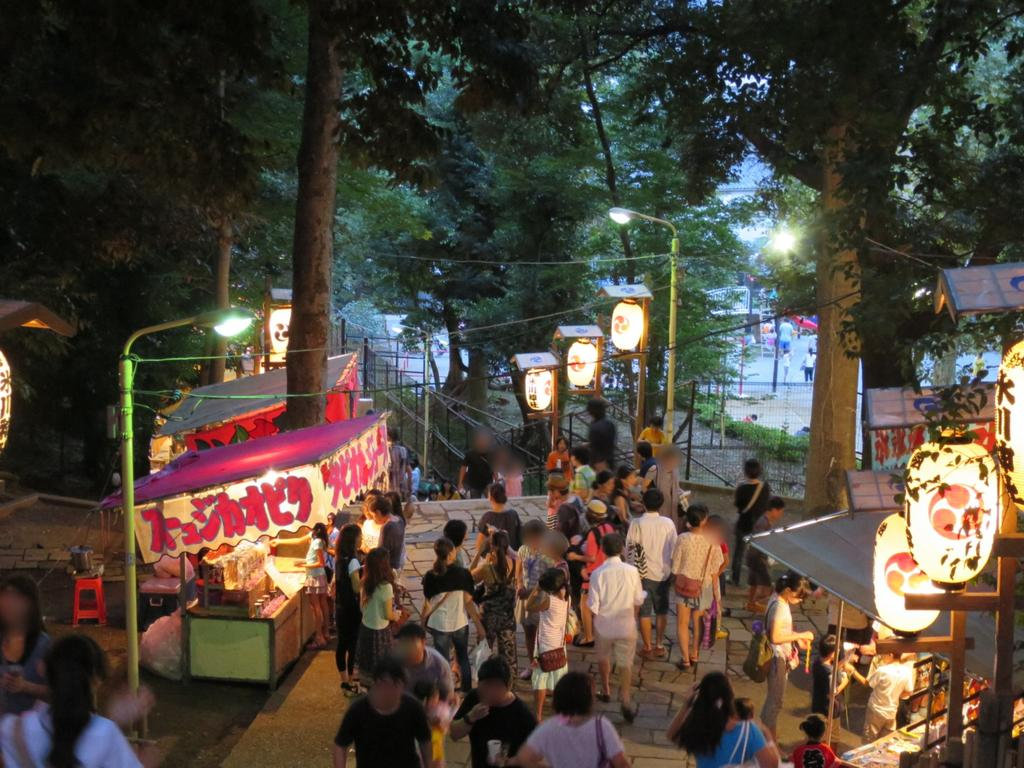What can be seen at the bottom side of the image? There are people at the bottom side of the image. What is located on the right side of the image? There are stalls on the right side of the image. What is located on the left side of the image? There are stalls on the left side of the image. What type of vegetation is visible at the top side of the image? There are trees at the top side of the image. Are there any bears driving a channel through the stalls in the image? No, there are no bears or channels present in the image. The image features people and stalls, with trees visible at the top side. 